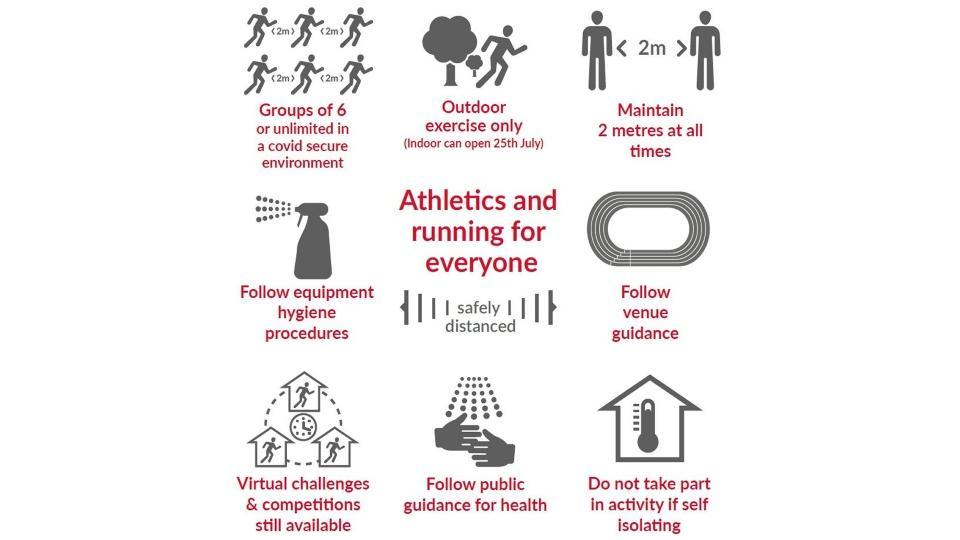What is the guideline given to athletes regarding equipment?
Answer the question with a short phrase. Follow equipment hygiene procedures On which condition athletes should retrain themselves from participating in competition? if self isolating How many guidelines for athletes are listed in the info graphic? 8 